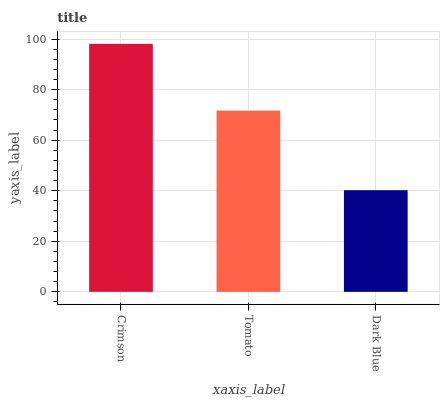Is Dark Blue the minimum?
Answer yes or no. Yes. Is Crimson the maximum?
Answer yes or no. Yes. Is Tomato the minimum?
Answer yes or no. No. Is Tomato the maximum?
Answer yes or no. No. Is Crimson greater than Tomato?
Answer yes or no. Yes. Is Tomato less than Crimson?
Answer yes or no. Yes. Is Tomato greater than Crimson?
Answer yes or no. No. Is Crimson less than Tomato?
Answer yes or no. No. Is Tomato the high median?
Answer yes or no. Yes. Is Tomato the low median?
Answer yes or no. Yes. Is Crimson the high median?
Answer yes or no. No. Is Dark Blue the low median?
Answer yes or no. No. 